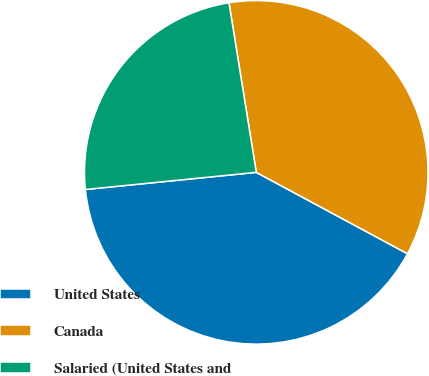Convert chart. <chart><loc_0><loc_0><loc_500><loc_500><pie_chart><fcel>United States<fcel>Canada<fcel>Salaried (United States and<nl><fcel>40.55%<fcel>35.4%<fcel>24.05%<nl></chart> 